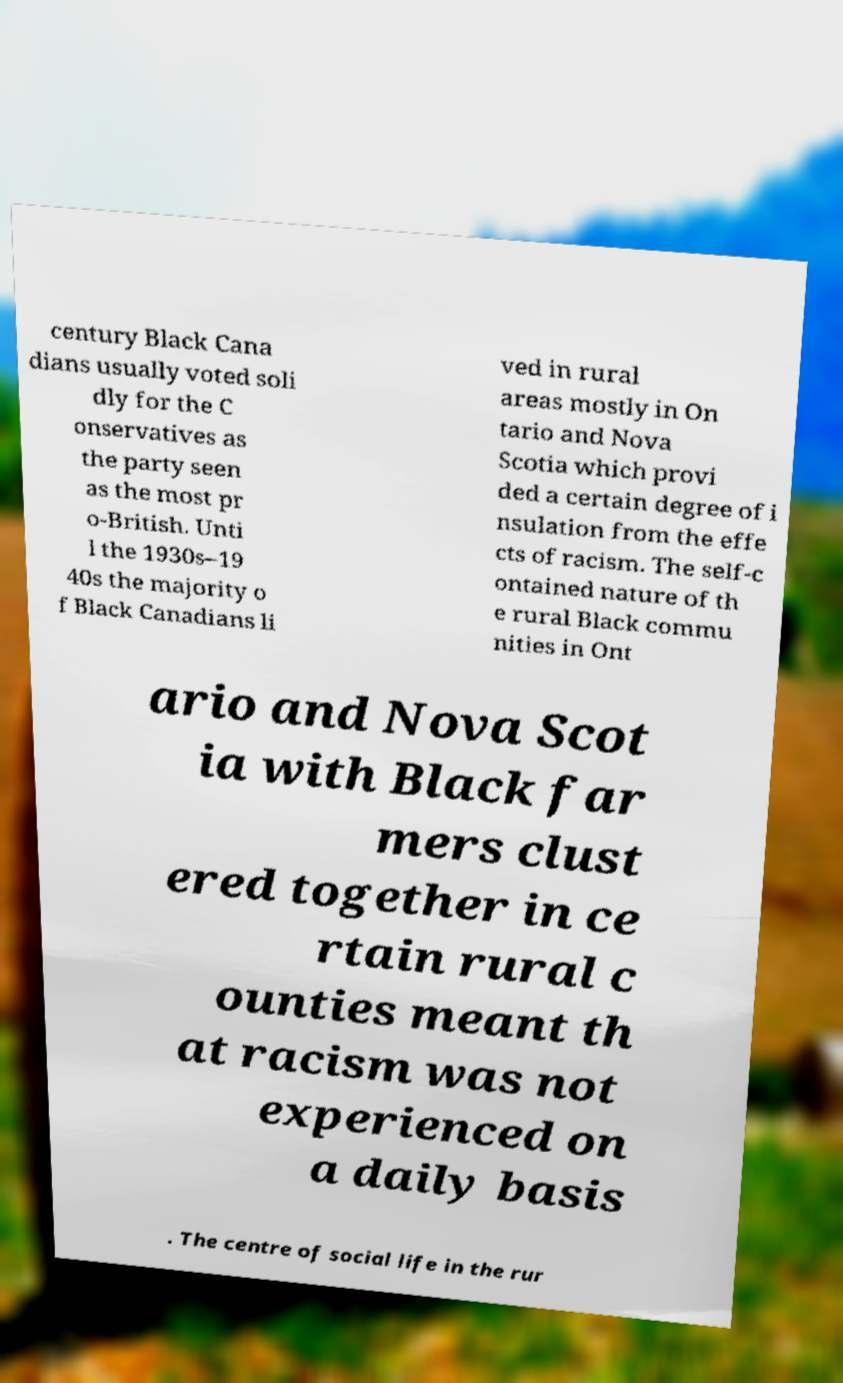Can you accurately transcribe the text from the provided image for me? century Black Cana dians usually voted soli dly for the C onservatives as the party seen as the most pr o-British. Unti l the 1930s–19 40s the majority o f Black Canadians li ved in rural areas mostly in On tario and Nova Scotia which provi ded a certain degree of i nsulation from the effe cts of racism. The self-c ontained nature of th e rural Black commu nities in Ont ario and Nova Scot ia with Black far mers clust ered together in ce rtain rural c ounties meant th at racism was not experienced on a daily basis . The centre of social life in the rur 